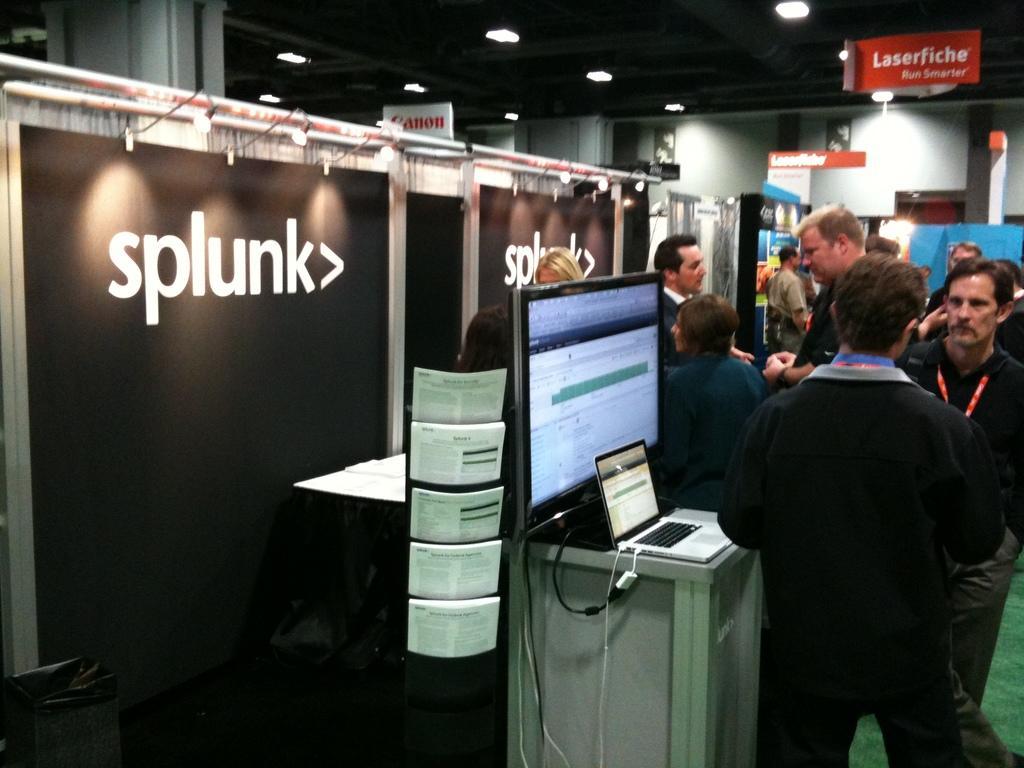Please provide a concise description of this image. On the right side, there are persons in different color dresses standing. Beside them, there is a screen and a laptop on the table. On the left side, there are black color boards arranged. In the background, there are lights attached to the roof, there are persons, there are hoardings and there is a wall. 